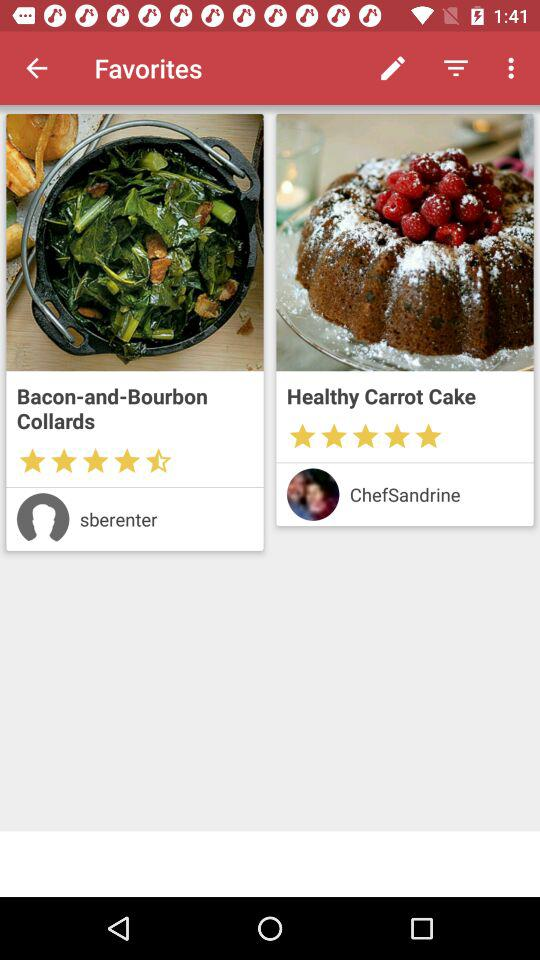What is the name of the chef? The name is ChefSandrine. 